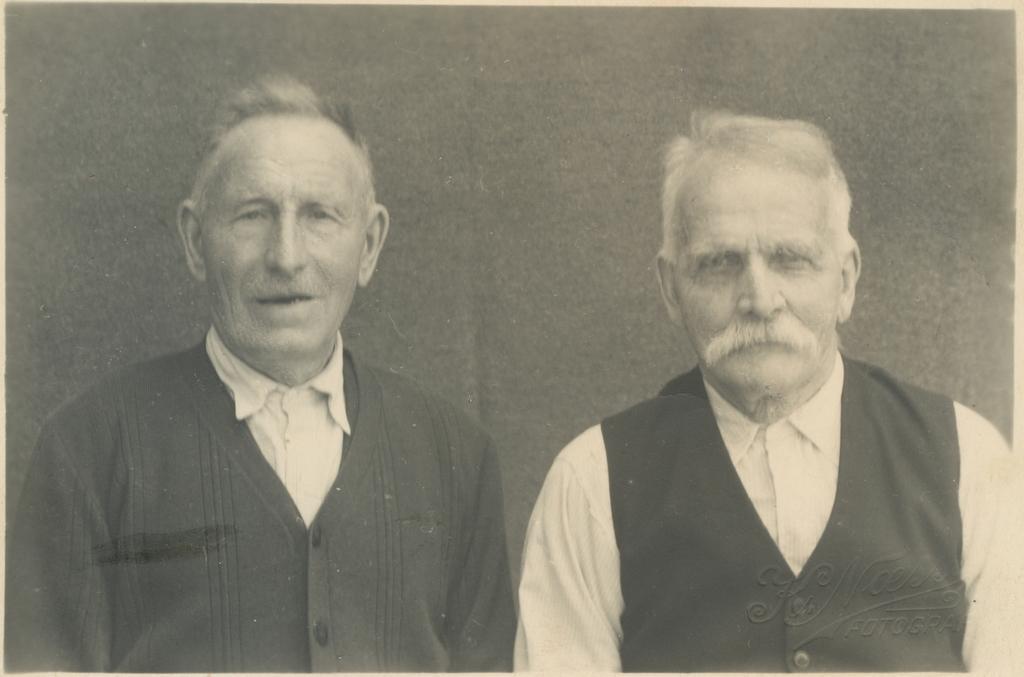In one or two sentences, can you explain what this image depicts? This is a black and white image. In this image we can see two persons. In the background there is wall. 